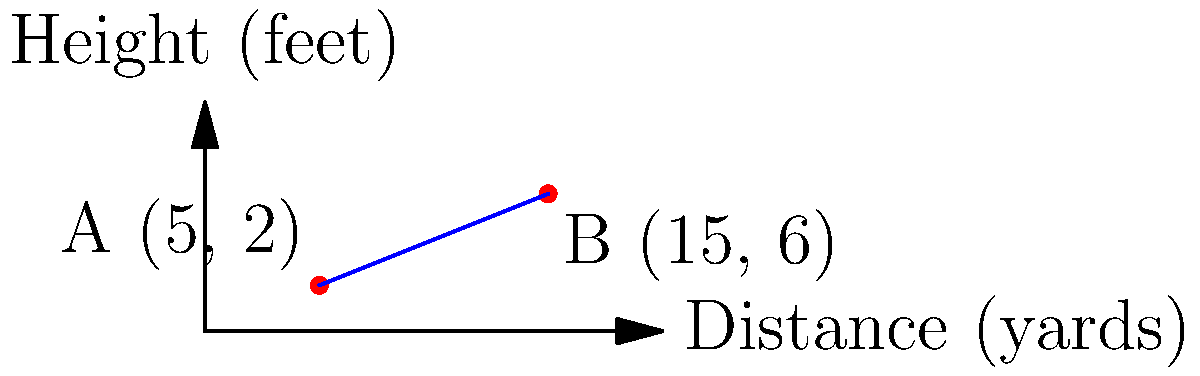At the famous Old Course in St Andrews, you're analyzing the slope of a particularly tricky putting green. Two points on the green, A and B, have been measured and plotted on a coordinate system where the x-axis represents the distance in yards and the y-axis represents the height in feet. Point A is at (5, 2) and Point B is at (15, 6). What is the slope of the putting green between these two points? To find the slope of the putting green between points A and B, we'll use the slope formula:

$$ \text{slope} = \frac{y_2 - y_1}{x_2 - x_1} $$

Where $(x_1, y_1)$ is the first point and $(x_2, y_2)$ is the second point.

Given:
Point A: $(x_1, y_1) = (5, 2)$
Point B: $(x_2, y_2) = (15, 6)$

Let's substitute these values into the formula:

$$ \text{slope} = \frac{6 - 2}{15 - 5} = \frac{4}{10} $$

Simplifying the fraction:

$$ \text{slope} = \frac{2}{5} = 0.4 $$

This means that for every 5 yards of horizontal distance, the green rises 2 feet. In golf terms, this would be considered a significant slope, making it a challenging putt.
Answer: $\frac{2}{5}$ or $0.4$ 